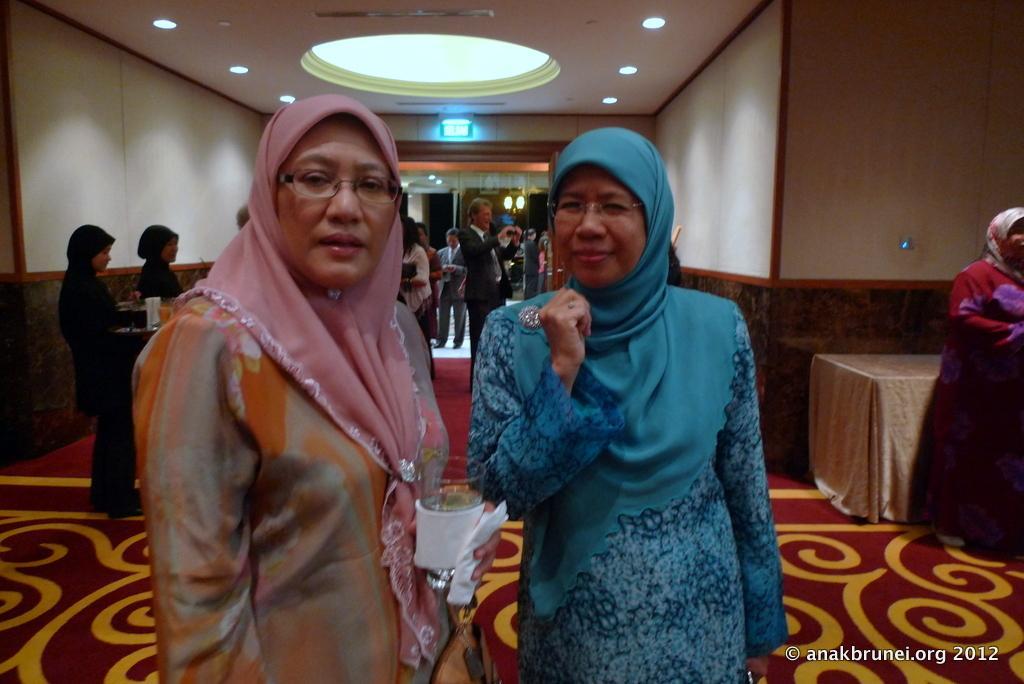In one or two sentences, can you explain what this image depicts? In the center of the image we can see two ladies standing. The lady standing on the left is holding a paper and a glass. In the background there are people and we can see a table. At the top there are lights and there is a door. 